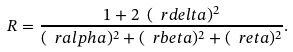Convert formula to latex. <formula><loc_0><loc_0><loc_500><loc_500>R = \frac { 1 + 2 \ ( \ r d e l t a ) ^ { 2 } } { ( \ r a l p h a ) ^ { 2 } + ( \ r b e t a ) ^ { 2 } + ( \ r e t a ) ^ { 2 } } .</formula> 